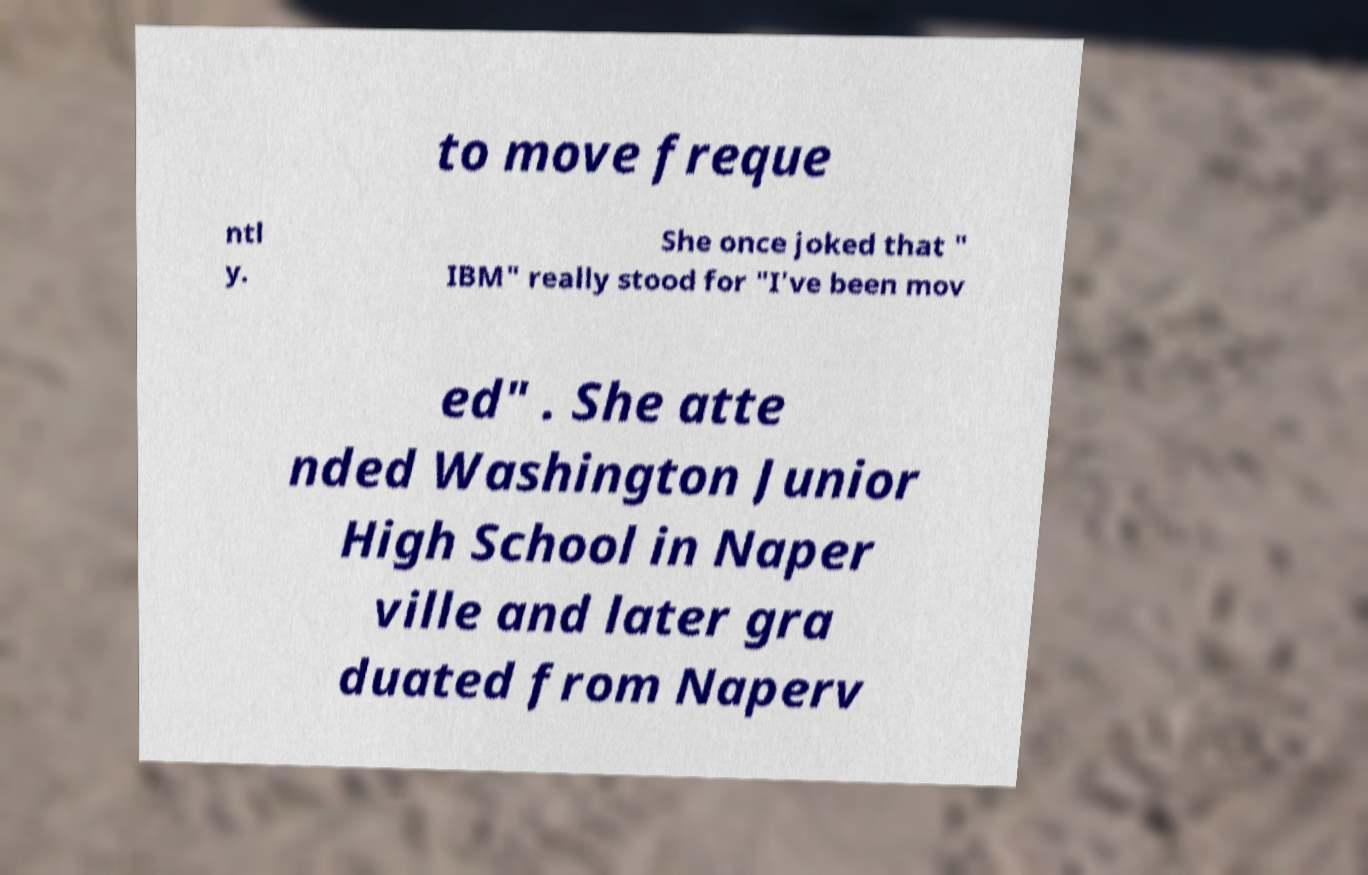Could you assist in decoding the text presented in this image and type it out clearly? to move freque ntl y. She once joked that " IBM" really stood for "I've been mov ed" . She atte nded Washington Junior High School in Naper ville and later gra duated from Naperv 